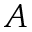<formula> <loc_0><loc_0><loc_500><loc_500>A</formula> 